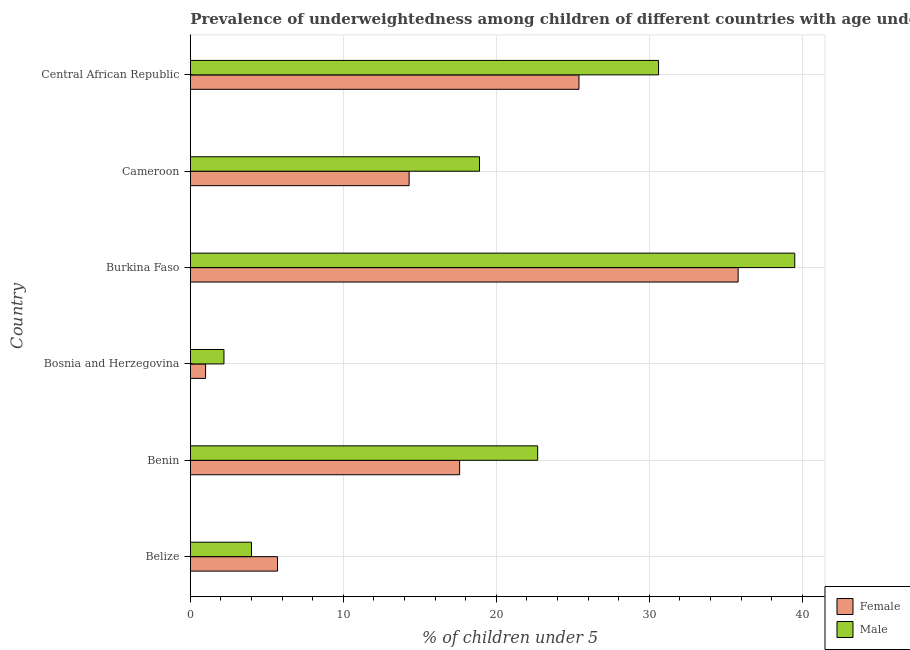Are the number of bars per tick equal to the number of legend labels?
Ensure brevity in your answer.  Yes. How many bars are there on the 2nd tick from the top?
Your response must be concise. 2. How many bars are there on the 1st tick from the bottom?
Give a very brief answer. 2. What is the label of the 2nd group of bars from the top?
Offer a terse response. Cameroon. What is the percentage of underweighted male children in Central African Republic?
Ensure brevity in your answer.  30.6. Across all countries, what is the maximum percentage of underweighted male children?
Make the answer very short. 39.5. Across all countries, what is the minimum percentage of underweighted female children?
Offer a very short reply. 1. In which country was the percentage of underweighted female children maximum?
Your answer should be very brief. Burkina Faso. In which country was the percentage of underweighted female children minimum?
Your response must be concise. Bosnia and Herzegovina. What is the total percentage of underweighted male children in the graph?
Ensure brevity in your answer.  117.9. What is the difference between the percentage of underweighted male children in Belize and that in Burkina Faso?
Keep it short and to the point. -35.5. What is the difference between the percentage of underweighted male children in Cameroon and the percentage of underweighted female children in Bosnia and Herzegovina?
Ensure brevity in your answer.  17.9. What is the average percentage of underweighted male children per country?
Your response must be concise. 19.65. What is the difference between the percentage of underweighted female children and percentage of underweighted male children in Belize?
Your answer should be compact. 1.7. In how many countries, is the percentage of underweighted male children greater than 38 %?
Provide a short and direct response. 1. What is the ratio of the percentage of underweighted male children in Benin to that in Cameroon?
Keep it short and to the point. 1.2. Is the difference between the percentage of underweighted female children in Cameroon and Central African Republic greater than the difference between the percentage of underweighted male children in Cameroon and Central African Republic?
Your answer should be very brief. Yes. What is the difference between the highest and the lowest percentage of underweighted female children?
Ensure brevity in your answer.  34.8. In how many countries, is the percentage of underweighted male children greater than the average percentage of underweighted male children taken over all countries?
Your response must be concise. 3. Are the values on the major ticks of X-axis written in scientific E-notation?
Your answer should be compact. No. Does the graph contain grids?
Your response must be concise. Yes. How are the legend labels stacked?
Provide a succinct answer. Vertical. What is the title of the graph?
Your answer should be compact. Prevalence of underweightedness among children of different countries with age under 5 years. What is the label or title of the X-axis?
Your answer should be very brief.  % of children under 5. What is the  % of children under 5 of Female in Belize?
Your answer should be compact. 5.7. What is the  % of children under 5 of Female in Benin?
Provide a short and direct response. 17.6. What is the  % of children under 5 of Male in Benin?
Your response must be concise. 22.7. What is the  % of children under 5 of Female in Bosnia and Herzegovina?
Provide a succinct answer. 1. What is the  % of children under 5 in Male in Bosnia and Herzegovina?
Offer a terse response. 2.2. What is the  % of children under 5 of Female in Burkina Faso?
Give a very brief answer. 35.8. What is the  % of children under 5 in Male in Burkina Faso?
Offer a very short reply. 39.5. What is the  % of children under 5 of Female in Cameroon?
Your answer should be very brief. 14.3. What is the  % of children under 5 in Male in Cameroon?
Provide a short and direct response. 18.9. What is the  % of children under 5 of Female in Central African Republic?
Give a very brief answer. 25.4. What is the  % of children under 5 of Male in Central African Republic?
Your answer should be very brief. 30.6. Across all countries, what is the maximum  % of children under 5 of Female?
Make the answer very short. 35.8. Across all countries, what is the maximum  % of children under 5 of Male?
Offer a terse response. 39.5. Across all countries, what is the minimum  % of children under 5 of Male?
Provide a succinct answer. 2.2. What is the total  % of children under 5 of Female in the graph?
Make the answer very short. 99.8. What is the total  % of children under 5 in Male in the graph?
Give a very brief answer. 117.9. What is the difference between the  % of children under 5 of Male in Belize and that in Benin?
Provide a short and direct response. -18.7. What is the difference between the  % of children under 5 of Female in Belize and that in Bosnia and Herzegovina?
Make the answer very short. 4.7. What is the difference between the  % of children under 5 of Male in Belize and that in Bosnia and Herzegovina?
Your answer should be very brief. 1.8. What is the difference between the  % of children under 5 of Female in Belize and that in Burkina Faso?
Provide a succinct answer. -30.1. What is the difference between the  % of children under 5 in Male in Belize and that in Burkina Faso?
Give a very brief answer. -35.5. What is the difference between the  % of children under 5 in Female in Belize and that in Cameroon?
Make the answer very short. -8.6. What is the difference between the  % of children under 5 of Male in Belize and that in Cameroon?
Give a very brief answer. -14.9. What is the difference between the  % of children under 5 of Female in Belize and that in Central African Republic?
Your answer should be very brief. -19.7. What is the difference between the  % of children under 5 in Male in Belize and that in Central African Republic?
Your response must be concise. -26.6. What is the difference between the  % of children under 5 of Female in Benin and that in Burkina Faso?
Your response must be concise. -18.2. What is the difference between the  % of children under 5 in Male in Benin and that in Burkina Faso?
Offer a terse response. -16.8. What is the difference between the  % of children under 5 in Female in Benin and that in Central African Republic?
Provide a short and direct response. -7.8. What is the difference between the  % of children under 5 of Female in Bosnia and Herzegovina and that in Burkina Faso?
Ensure brevity in your answer.  -34.8. What is the difference between the  % of children under 5 of Male in Bosnia and Herzegovina and that in Burkina Faso?
Your answer should be compact. -37.3. What is the difference between the  % of children under 5 of Female in Bosnia and Herzegovina and that in Cameroon?
Your response must be concise. -13.3. What is the difference between the  % of children under 5 in Male in Bosnia and Herzegovina and that in Cameroon?
Your answer should be compact. -16.7. What is the difference between the  % of children under 5 of Female in Bosnia and Herzegovina and that in Central African Republic?
Offer a very short reply. -24.4. What is the difference between the  % of children under 5 in Male in Bosnia and Herzegovina and that in Central African Republic?
Keep it short and to the point. -28.4. What is the difference between the  % of children under 5 of Male in Burkina Faso and that in Cameroon?
Make the answer very short. 20.6. What is the difference between the  % of children under 5 of Male in Cameroon and that in Central African Republic?
Your answer should be compact. -11.7. What is the difference between the  % of children under 5 of Female in Belize and the  % of children under 5 of Male in Bosnia and Herzegovina?
Offer a terse response. 3.5. What is the difference between the  % of children under 5 of Female in Belize and the  % of children under 5 of Male in Burkina Faso?
Keep it short and to the point. -33.8. What is the difference between the  % of children under 5 in Female in Belize and the  % of children under 5 in Male in Cameroon?
Make the answer very short. -13.2. What is the difference between the  % of children under 5 of Female in Belize and the  % of children under 5 of Male in Central African Republic?
Give a very brief answer. -24.9. What is the difference between the  % of children under 5 in Female in Benin and the  % of children under 5 in Male in Bosnia and Herzegovina?
Your answer should be compact. 15.4. What is the difference between the  % of children under 5 in Female in Benin and the  % of children under 5 in Male in Burkina Faso?
Make the answer very short. -21.9. What is the difference between the  % of children under 5 of Female in Bosnia and Herzegovina and the  % of children under 5 of Male in Burkina Faso?
Your answer should be very brief. -38.5. What is the difference between the  % of children under 5 in Female in Bosnia and Herzegovina and the  % of children under 5 in Male in Cameroon?
Offer a very short reply. -17.9. What is the difference between the  % of children under 5 of Female in Bosnia and Herzegovina and the  % of children under 5 of Male in Central African Republic?
Offer a terse response. -29.6. What is the difference between the  % of children under 5 in Female in Burkina Faso and the  % of children under 5 in Male in Cameroon?
Keep it short and to the point. 16.9. What is the difference between the  % of children under 5 of Female in Burkina Faso and the  % of children under 5 of Male in Central African Republic?
Give a very brief answer. 5.2. What is the difference between the  % of children under 5 in Female in Cameroon and the  % of children under 5 in Male in Central African Republic?
Your response must be concise. -16.3. What is the average  % of children under 5 of Female per country?
Keep it short and to the point. 16.63. What is the average  % of children under 5 of Male per country?
Your answer should be very brief. 19.65. What is the difference between the  % of children under 5 of Female and  % of children under 5 of Male in Benin?
Keep it short and to the point. -5.1. What is the difference between the  % of children under 5 in Female and  % of children under 5 in Male in Bosnia and Herzegovina?
Keep it short and to the point. -1.2. What is the difference between the  % of children under 5 in Female and  % of children under 5 in Male in Burkina Faso?
Your answer should be very brief. -3.7. What is the ratio of the  % of children under 5 in Female in Belize to that in Benin?
Your answer should be compact. 0.32. What is the ratio of the  % of children under 5 of Male in Belize to that in Benin?
Ensure brevity in your answer.  0.18. What is the ratio of the  % of children under 5 of Male in Belize to that in Bosnia and Herzegovina?
Offer a terse response. 1.82. What is the ratio of the  % of children under 5 of Female in Belize to that in Burkina Faso?
Your response must be concise. 0.16. What is the ratio of the  % of children under 5 of Male in Belize to that in Burkina Faso?
Ensure brevity in your answer.  0.1. What is the ratio of the  % of children under 5 in Female in Belize to that in Cameroon?
Give a very brief answer. 0.4. What is the ratio of the  % of children under 5 of Male in Belize to that in Cameroon?
Offer a terse response. 0.21. What is the ratio of the  % of children under 5 in Female in Belize to that in Central African Republic?
Offer a very short reply. 0.22. What is the ratio of the  % of children under 5 of Male in Belize to that in Central African Republic?
Provide a succinct answer. 0.13. What is the ratio of the  % of children under 5 of Female in Benin to that in Bosnia and Herzegovina?
Keep it short and to the point. 17.6. What is the ratio of the  % of children under 5 in Male in Benin to that in Bosnia and Herzegovina?
Keep it short and to the point. 10.32. What is the ratio of the  % of children under 5 in Female in Benin to that in Burkina Faso?
Your response must be concise. 0.49. What is the ratio of the  % of children under 5 in Male in Benin to that in Burkina Faso?
Ensure brevity in your answer.  0.57. What is the ratio of the  % of children under 5 in Female in Benin to that in Cameroon?
Give a very brief answer. 1.23. What is the ratio of the  % of children under 5 in Male in Benin to that in Cameroon?
Offer a very short reply. 1.2. What is the ratio of the  % of children under 5 of Female in Benin to that in Central African Republic?
Offer a very short reply. 0.69. What is the ratio of the  % of children under 5 of Male in Benin to that in Central African Republic?
Ensure brevity in your answer.  0.74. What is the ratio of the  % of children under 5 of Female in Bosnia and Herzegovina to that in Burkina Faso?
Ensure brevity in your answer.  0.03. What is the ratio of the  % of children under 5 in Male in Bosnia and Herzegovina to that in Burkina Faso?
Make the answer very short. 0.06. What is the ratio of the  % of children under 5 of Female in Bosnia and Herzegovina to that in Cameroon?
Give a very brief answer. 0.07. What is the ratio of the  % of children under 5 of Male in Bosnia and Herzegovina to that in Cameroon?
Offer a terse response. 0.12. What is the ratio of the  % of children under 5 in Female in Bosnia and Herzegovina to that in Central African Republic?
Give a very brief answer. 0.04. What is the ratio of the  % of children under 5 of Male in Bosnia and Herzegovina to that in Central African Republic?
Your answer should be very brief. 0.07. What is the ratio of the  % of children under 5 of Female in Burkina Faso to that in Cameroon?
Give a very brief answer. 2.5. What is the ratio of the  % of children under 5 of Male in Burkina Faso to that in Cameroon?
Provide a succinct answer. 2.09. What is the ratio of the  % of children under 5 of Female in Burkina Faso to that in Central African Republic?
Your answer should be compact. 1.41. What is the ratio of the  % of children under 5 in Male in Burkina Faso to that in Central African Republic?
Keep it short and to the point. 1.29. What is the ratio of the  % of children under 5 of Female in Cameroon to that in Central African Republic?
Provide a succinct answer. 0.56. What is the ratio of the  % of children under 5 in Male in Cameroon to that in Central African Republic?
Offer a very short reply. 0.62. What is the difference between the highest and the second highest  % of children under 5 in Male?
Provide a succinct answer. 8.9. What is the difference between the highest and the lowest  % of children under 5 of Female?
Your answer should be very brief. 34.8. What is the difference between the highest and the lowest  % of children under 5 in Male?
Give a very brief answer. 37.3. 